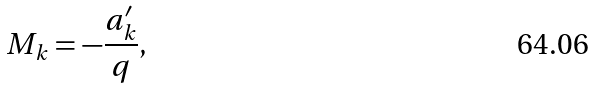Convert formula to latex. <formula><loc_0><loc_0><loc_500><loc_500>M _ { k } = - \frac { a _ { k } ^ { \prime } } { q } ,</formula> 